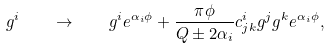Convert formula to latex. <formula><loc_0><loc_0><loc_500><loc_500>g ^ { i } \quad \to \quad g ^ { i } e ^ { \alpha _ { i } \phi } + \frac { \pi \phi } { Q \pm 2 \alpha _ { i } } c ^ { i } _ { j k } g ^ { j } g ^ { k } e ^ { \alpha _ { i } \phi } ,</formula> 